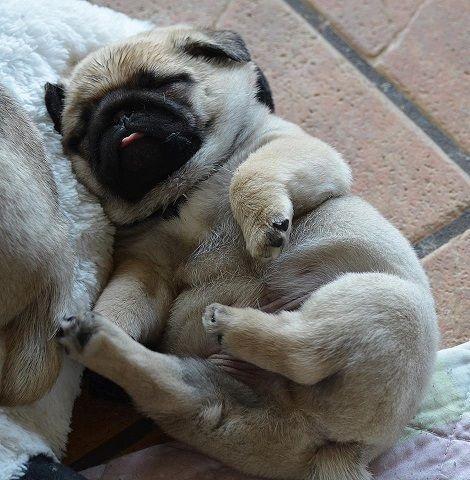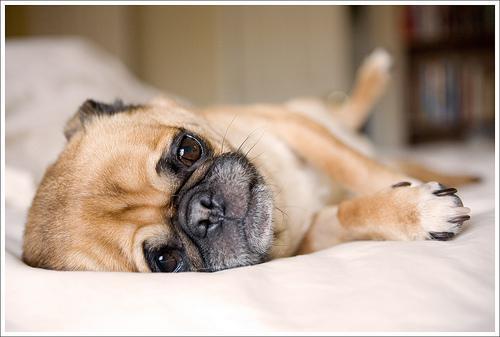The first image is the image on the left, the second image is the image on the right. Given the left and right images, does the statement "The dog on the right is posing with a black and white ball" hold true? Answer yes or no. No. The first image is the image on the left, the second image is the image on the right. Analyze the images presented: Is the assertion "In one image a dog is with a soccer ball toy." valid? Answer yes or no. No. 